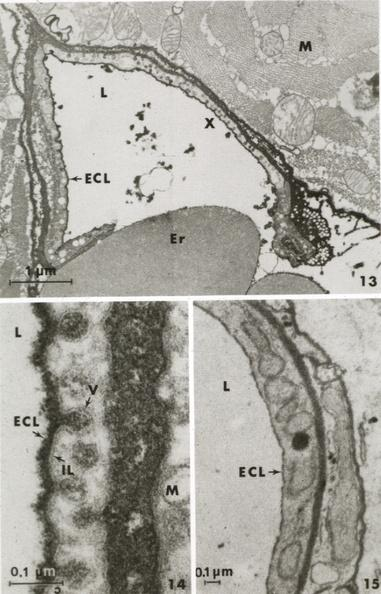s vasculature present?
Answer the question using a single word or phrase. Yes 